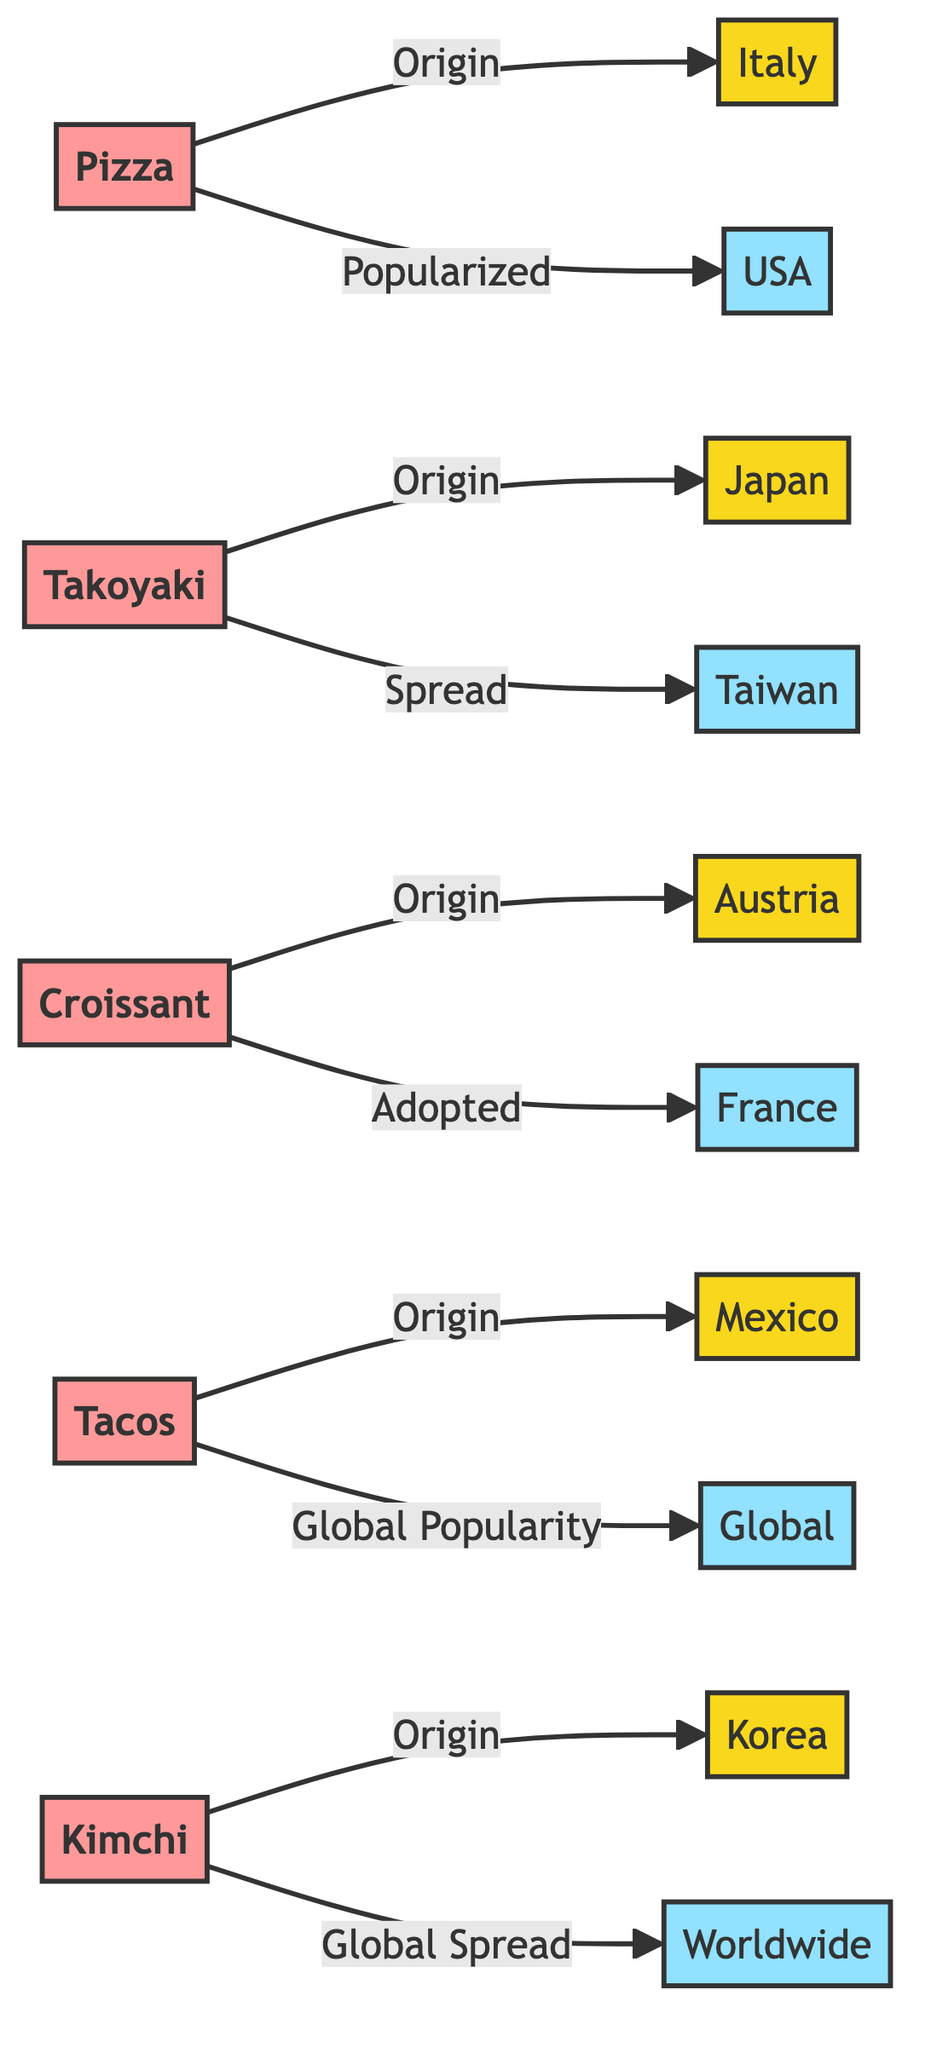What is the origin of Pizza? According to the diagram, Pizza has its origin in Italy, which is indicated by the direct link from "Pizza" to "Italy".
Answer: Italy Which snack is widely spread in Korea? The diagram shows that Kimchi originated in Korea and is spread worldwide, indicated by the link from "Kimchi" to "Worldwide".
Answer: Worldwide How many snacks originate from Austria? From the diagram, it shows that Croissant is the only snack listed with an origin in Austria, so the count is one.
Answer: 1 What is the relationship between Tacos and Mexico? The diagram indicates that Tacos have their origin in Mexico, shown by the link from "Tacos" to "Mexico". This indicates a direct relationship where Tacos originated in Mexico.
Answer: Origin Which two countries are associated with Croissant? The diagram indicates that Croissant originates from Austria and is adopted in France, which are the two countries associated with Croissant.
Answer: Austria, France What type of popularity do Tacos have? The diagram specifies that Tacos have a "Global Popularity", which connects Tacos to a global spread. This highlights how Tacos are recognized beyond their original place.
Answer: Global Popularity What is the spread location for Takoyaki? According to the diagram, Takoyaki is spread in Taiwan, shown by the link from "Takoyaki" to "Taiwan".
Answer: Taiwan How many snacks in the diagram originated from Asian countries? By reviewing the diagram, Takoyaki from Japan, Tacos from Mexico, and Kimchi from Korea meet the criteria as Asian snacks, so there are three Asian-origin snacks.
Answer: 3 